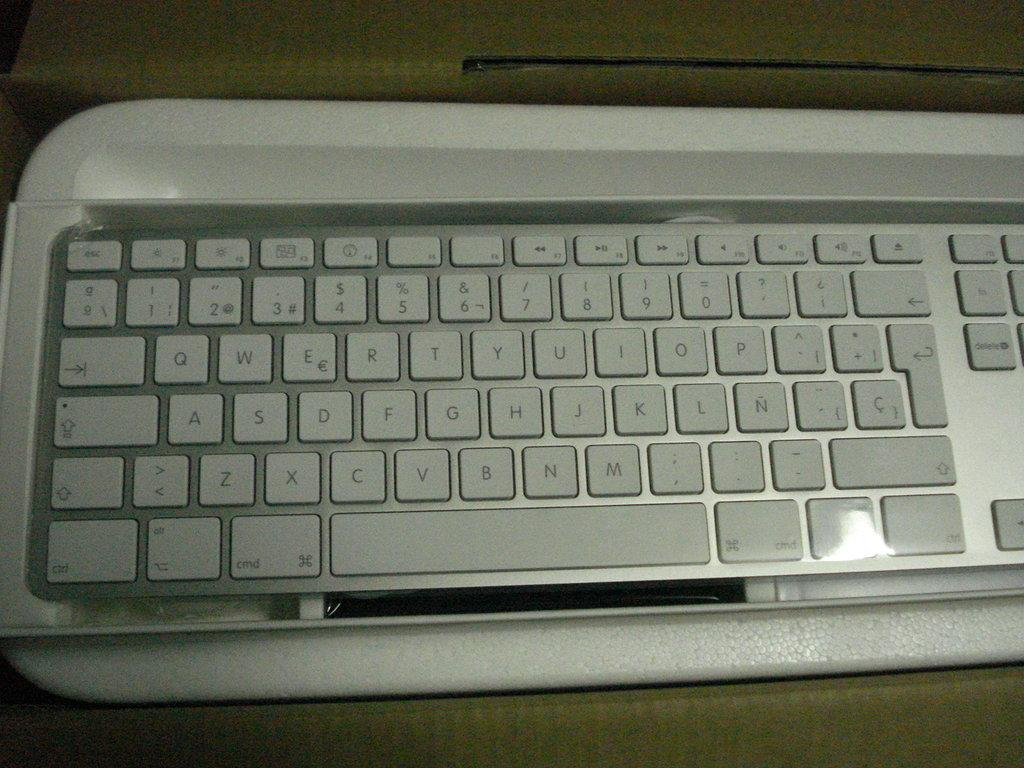<image>
Present a compact description of the photo's key features. Keyboard with the letters S,D,F and more visible. 